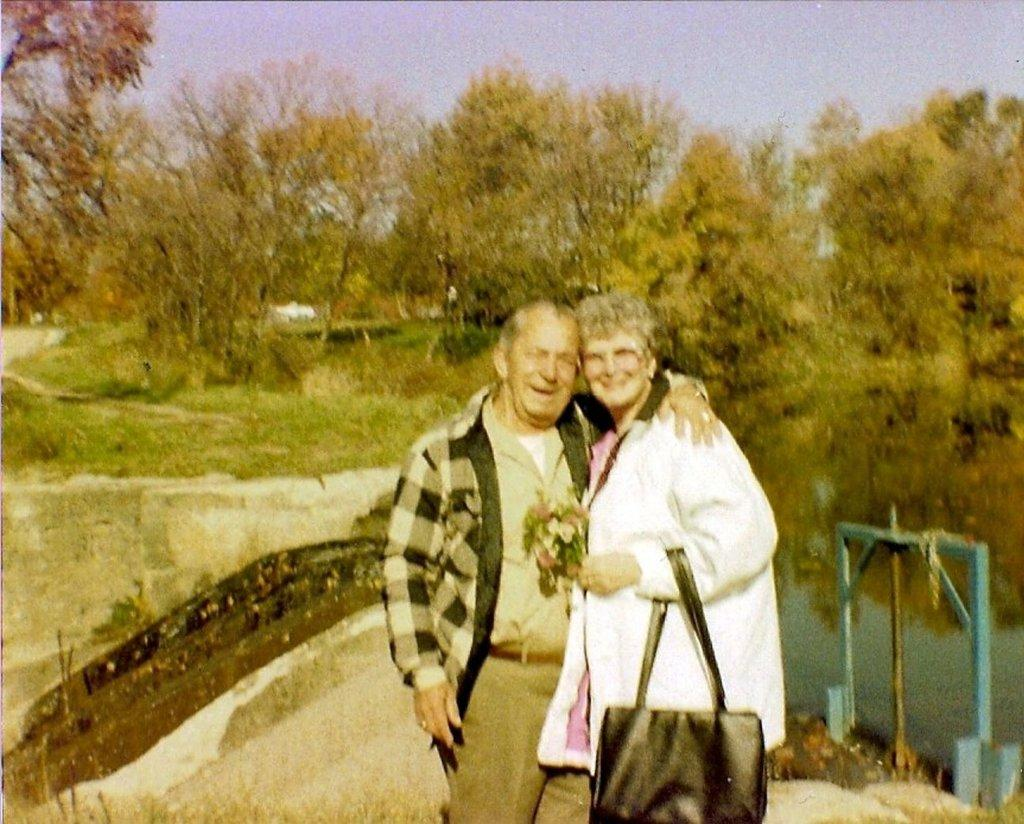Who are the main subjects in the image? There is an old couple in the middle of the image. What is located behind the old couple? There is a pond behind the old couple. What can be seen in the distance in the image? There are trees visible in the background of the image. What is the price of the rabbits seen in the image? There are no rabbits present in the image, so it is not possible to determine their price. 